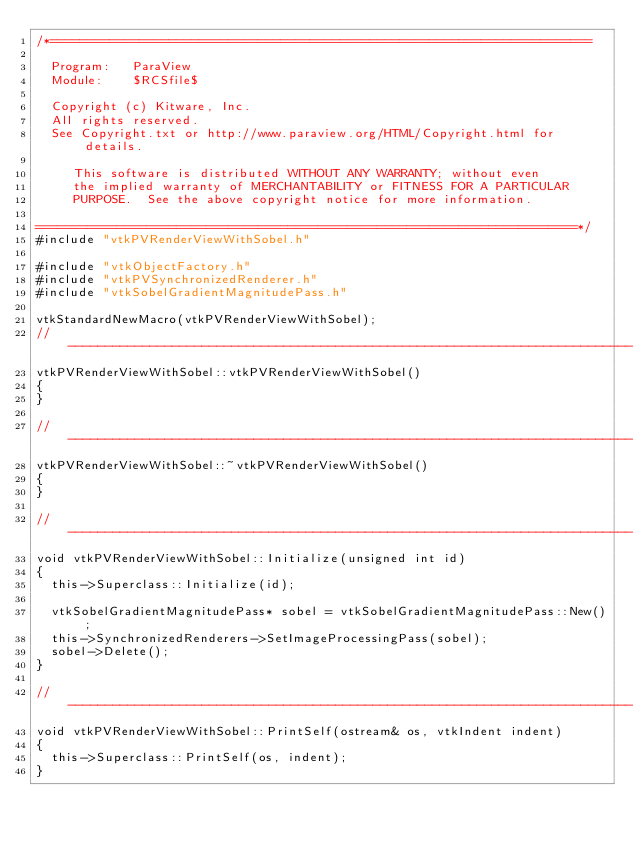Convert code to text. <code><loc_0><loc_0><loc_500><loc_500><_C++_>/*=========================================================================

  Program:   ParaView
  Module:    $RCSfile$

  Copyright (c) Kitware, Inc.
  All rights reserved.
  See Copyright.txt or http://www.paraview.org/HTML/Copyright.html for details.

     This software is distributed WITHOUT ANY WARRANTY; without even
     the implied warranty of MERCHANTABILITY or FITNESS FOR A PARTICULAR
     PURPOSE.  See the above copyright notice for more information.

=========================================================================*/
#include "vtkPVRenderViewWithSobel.h"

#include "vtkObjectFactory.h"
#include "vtkPVSynchronizedRenderer.h"
#include "vtkSobelGradientMagnitudePass.h"

vtkStandardNewMacro(vtkPVRenderViewWithSobel);
//----------------------------------------------------------------------------
vtkPVRenderViewWithSobel::vtkPVRenderViewWithSobel()
{
}

//----------------------------------------------------------------------------
vtkPVRenderViewWithSobel::~vtkPVRenderViewWithSobel()
{
}

//----------------------------------------------------------------------------
void vtkPVRenderViewWithSobel::Initialize(unsigned int id)
{
  this->Superclass::Initialize(id);

  vtkSobelGradientMagnitudePass* sobel = vtkSobelGradientMagnitudePass::New();
  this->SynchronizedRenderers->SetImageProcessingPass(sobel);
  sobel->Delete();
}

//----------------------------------------------------------------------------
void vtkPVRenderViewWithSobel::PrintSelf(ostream& os, vtkIndent indent)
{
  this->Superclass::PrintSelf(os, indent);
}
</code> 